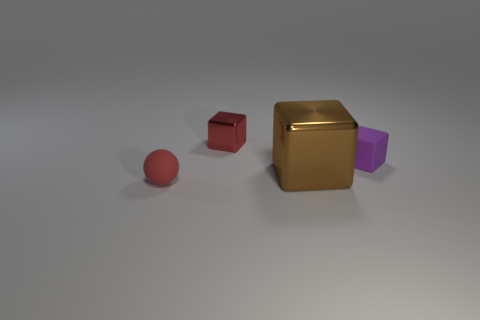How many small objects are in front of the brown object and right of the big shiny thing?
Offer a very short reply. 0. What number of things are matte spheres or tiny things behind the tiny red rubber sphere?
Offer a very short reply. 3. There is a thing that is the same material as the tiny purple cube; what size is it?
Your answer should be very brief. Small. There is a small red object in front of the tiny thing that is on the right side of the tiny shiny cube; what shape is it?
Provide a short and direct response. Sphere. How many purple objects are shiny things or big shiny balls?
Provide a succinct answer. 0. There is a tiny block that is behind the rubber object that is right of the tiny red metallic cube; are there any purple matte objects that are behind it?
Ensure brevity in your answer.  No. The matte thing that is the same color as the tiny metallic thing is what shape?
Your answer should be compact. Sphere. Is there any other thing that has the same material as the small red ball?
Provide a succinct answer. Yes. What number of small things are either brown objects or blue objects?
Your answer should be compact. 0. There is a metal thing in front of the red shiny object; does it have the same shape as the small shiny thing?
Offer a terse response. Yes. 